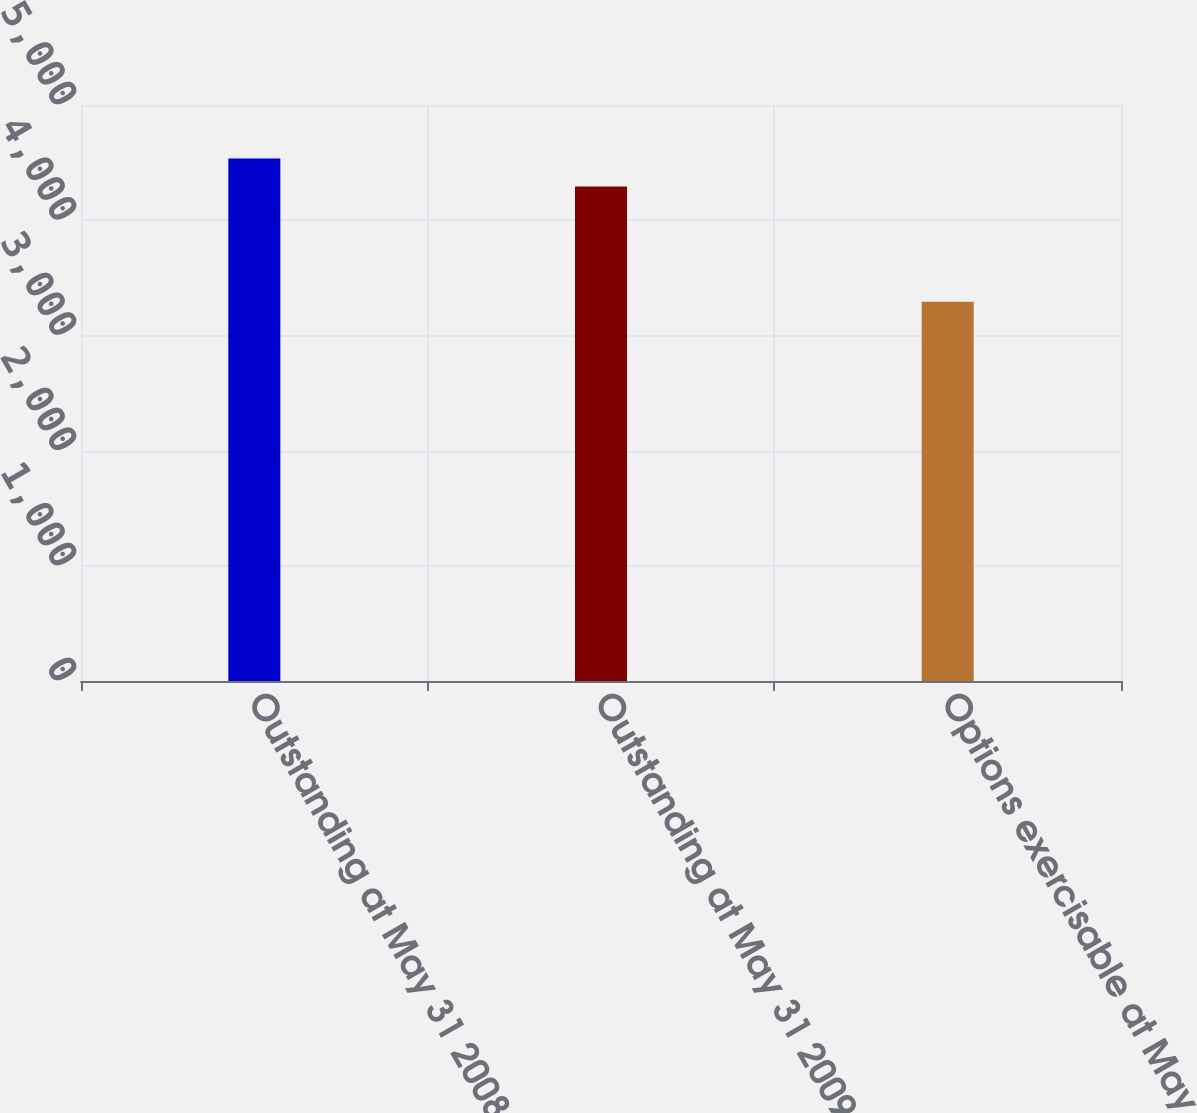Convert chart. <chart><loc_0><loc_0><loc_500><loc_500><bar_chart><fcel>Outstanding at May 31 2008<fcel>Outstanding at May 31 2009<fcel>Options exercisable at May 31<nl><fcel>4536<fcel>4293<fcel>3292<nl></chart> 